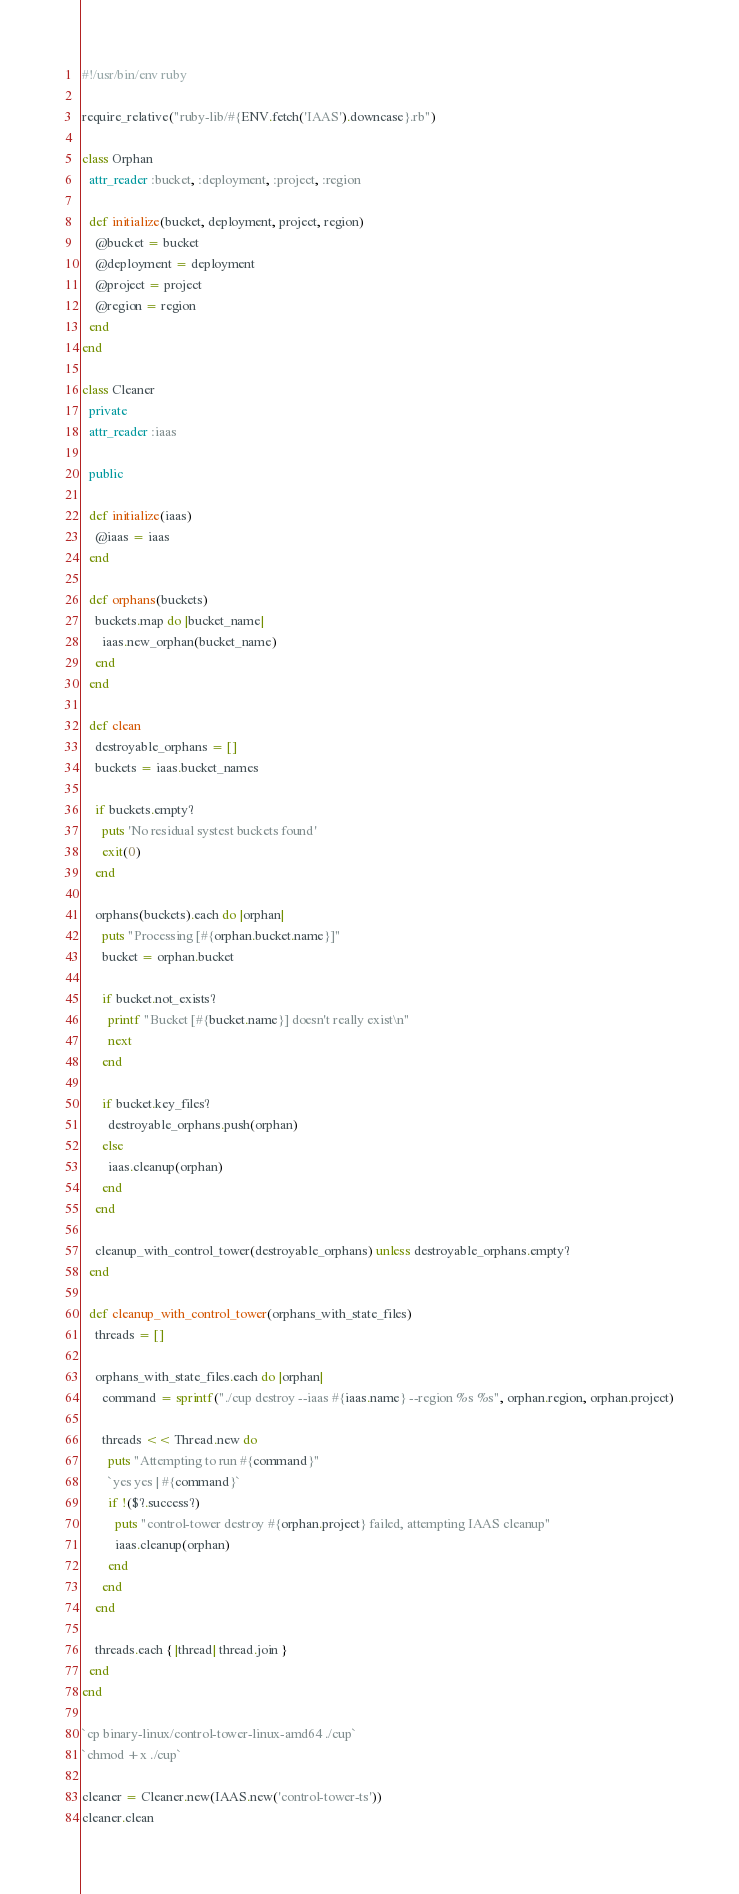<code> <loc_0><loc_0><loc_500><loc_500><_Ruby_>#!/usr/bin/env ruby

require_relative("ruby-lib/#{ENV.fetch('IAAS').downcase}.rb")

class Orphan
  attr_reader :bucket, :deployment, :project, :region

  def initialize(bucket, deployment, project, region)
    @bucket = bucket
    @deployment = deployment
    @project = project
    @region = region
  end
end

class Cleaner
  private
  attr_reader :iaas

  public

  def initialize(iaas)
    @iaas = iaas
  end

  def orphans(buckets)
    buckets.map do |bucket_name|
      iaas.new_orphan(bucket_name)
    end
  end

  def clean
    destroyable_orphans = []
    buckets = iaas.bucket_names

    if buckets.empty?
      puts 'No residual systest buckets found'
      exit(0)
    end

    orphans(buckets).each do |orphan|
      puts "Processing [#{orphan.bucket.name}]"
      bucket = orphan.bucket

      if bucket.not_exists?
        printf "Bucket [#{bucket.name}] doesn't really exist\n"
        next
      end

      if bucket.key_files?
        destroyable_orphans.push(orphan)
      else
        iaas.cleanup(orphan)
      end
    end

    cleanup_with_control_tower(destroyable_orphans) unless destroyable_orphans.empty?
  end

  def cleanup_with_control_tower(orphans_with_state_files)
    threads = []

    orphans_with_state_files.each do |orphan|
      command = sprintf("./cup destroy --iaas #{iaas.name} --region %s %s", orphan.region, orphan.project)

      threads << Thread.new do
        puts "Attempting to run #{command}"
        `yes yes | #{command}`
        if !($?.success?)
          puts "control-tower destroy #{orphan.project} failed, attempting IAAS cleanup"
          iaas.cleanup(orphan)
        end
      end
    end

    threads.each { |thread| thread.join }
  end
end

`cp binary-linux/control-tower-linux-amd64 ./cup`
`chmod +x ./cup`

cleaner = Cleaner.new(IAAS.new('control-tower-ts'))
cleaner.clean
</code> 